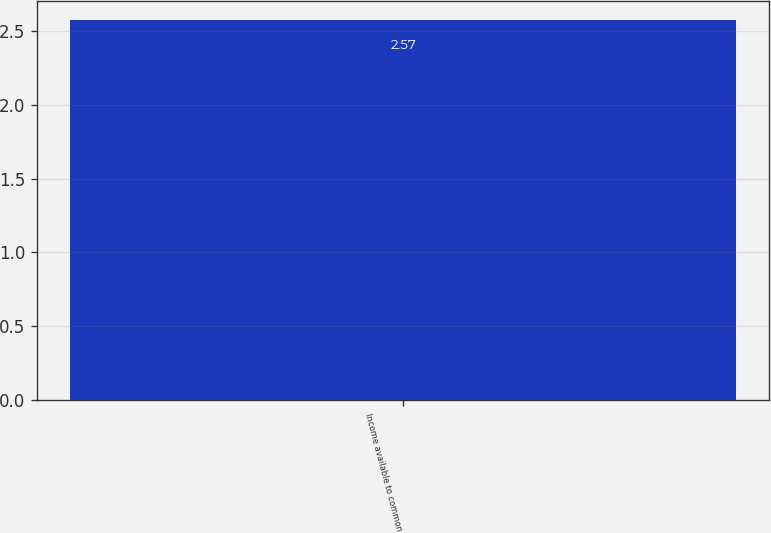<chart> <loc_0><loc_0><loc_500><loc_500><bar_chart><fcel>Income available to common<nl><fcel>2.57<nl></chart> 